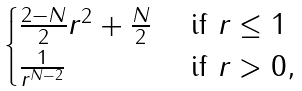<formula> <loc_0><loc_0><loc_500><loc_500>\begin{cases} \frac { 2 - N } { 2 } r ^ { 2 } + \frac { N } { 2 } & \text { if } r \leq 1 \\ \frac { 1 } { r ^ { N - 2 } } & \text { if } r > 0 , \end{cases}</formula> 